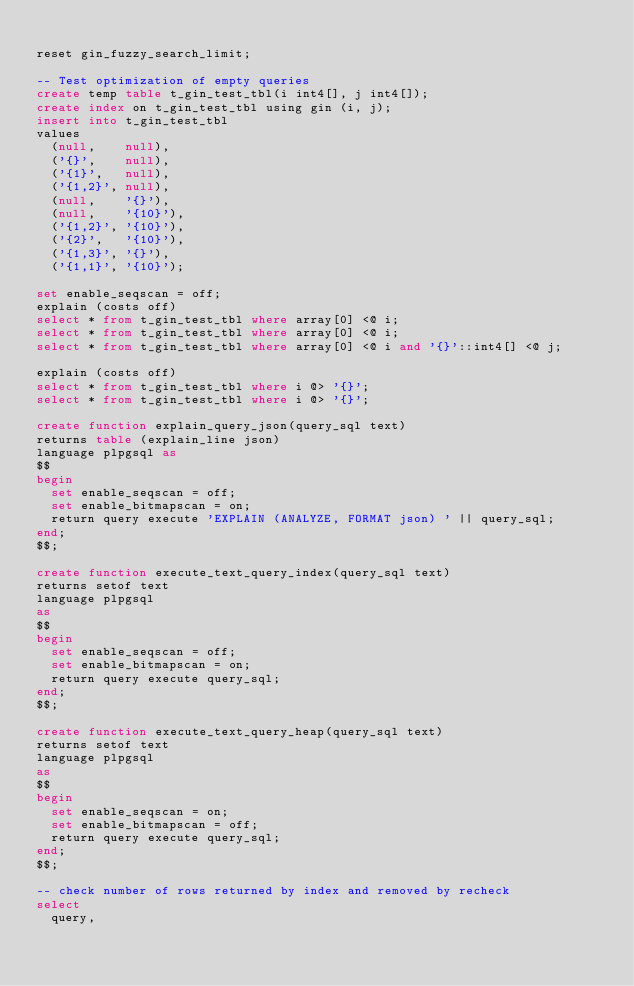Convert code to text. <code><loc_0><loc_0><loc_500><loc_500><_SQL_>
reset gin_fuzzy_search_limit;

-- Test optimization of empty queries
create temp table t_gin_test_tbl(i int4[], j int4[]);
create index on t_gin_test_tbl using gin (i, j);
insert into t_gin_test_tbl
values
  (null,    null),
  ('{}',    null),
  ('{1}',   null),
  ('{1,2}', null),
  (null,    '{}'),
  (null,    '{10}'),
  ('{1,2}', '{10}'),
  ('{2}',   '{10}'),
  ('{1,3}', '{}'),
  ('{1,1}', '{10}');

set enable_seqscan = off;
explain (costs off)
select * from t_gin_test_tbl where array[0] <@ i;
select * from t_gin_test_tbl where array[0] <@ i;
select * from t_gin_test_tbl where array[0] <@ i and '{}'::int4[] <@ j;

explain (costs off)
select * from t_gin_test_tbl where i @> '{}';
select * from t_gin_test_tbl where i @> '{}';

create function explain_query_json(query_sql text)
returns table (explain_line json)
language plpgsql as
$$
begin
  set enable_seqscan = off;
  set enable_bitmapscan = on;
  return query execute 'EXPLAIN (ANALYZE, FORMAT json) ' || query_sql;
end;
$$;

create function execute_text_query_index(query_sql text)
returns setof text
language plpgsql
as
$$
begin
  set enable_seqscan = off;
  set enable_bitmapscan = on;
  return query execute query_sql;
end;
$$;

create function execute_text_query_heap(query_sql text)
returns setof text
language plpgsql
as
$$
begin
  set enable_seqscan = on;
  set enable_bitmapscan = off;
  return query execute query_sql;
end;
$$;

-- check number of rows returned by index and removed by recheck
select
  query,</code> 